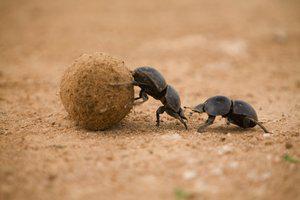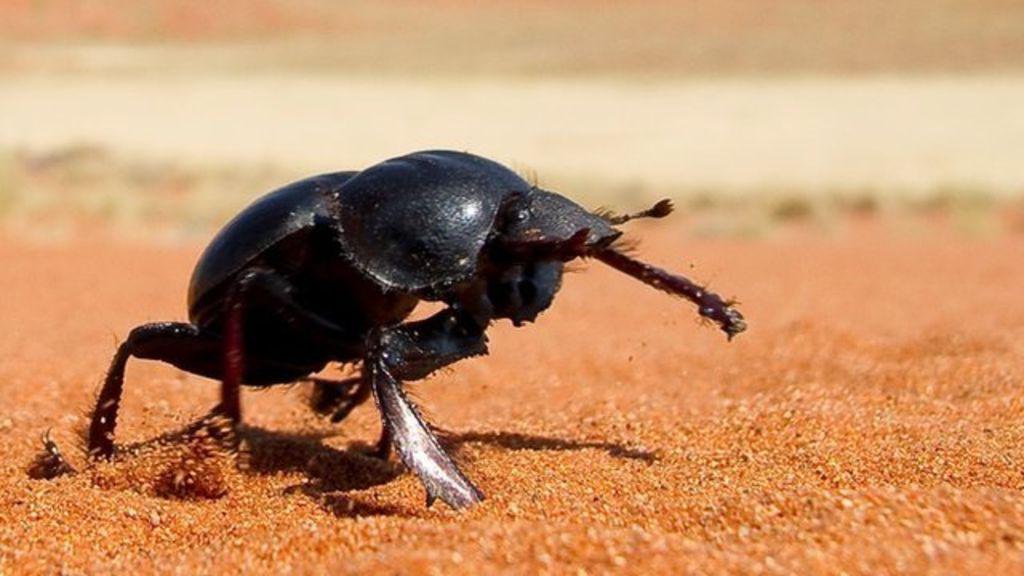The first image is the image on the left, the second image is the image on the right. For the images shown, is this caption "There are two beetles in the right image." true? Answer yes or no. No. The first image is the image on the left, the second image is the image on the right. Assess this claim about the two images: "Each image includes at least one beetle in contact with one brown ball.". Correct or not? Answer yes or no. No. 